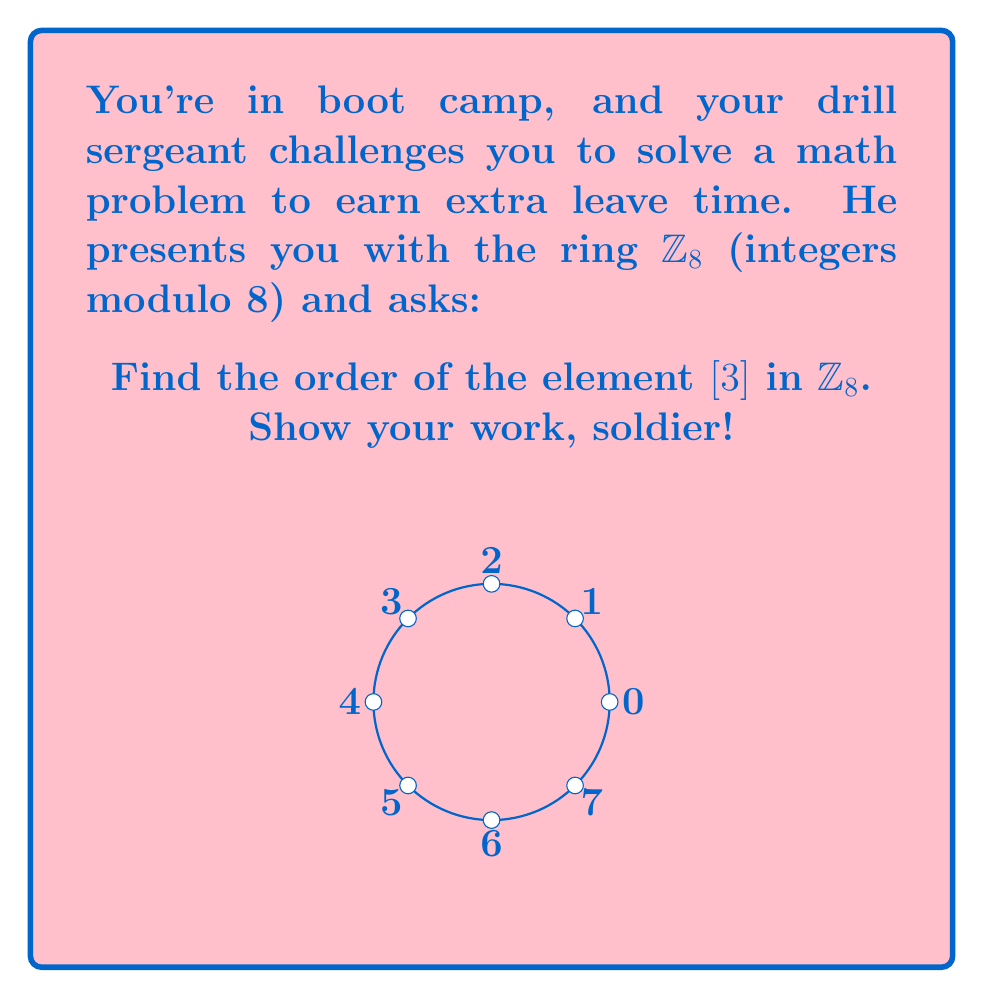Can you solve this math problem? To find the order of $[3]$ in $\mathbb{Z}_8$, we need to determine the smallest positive integer $n$ such that $[3]^n = [1]$ (the multiplicative identity in $\mathbb{Z}_8$).

Let's compute the powers of $[3]$ in $\mathbb{Z}_8$:

1) $[3]^1 = [3]$
2) $[3]^2 = [3] \cdot [3] = [9] = [1]$ (since $9 \equiv 1 \pmod{8}$)

We've found that $[3]^2 = [1]$, so the order of $[3]$ is 2.

To verify:
$$[3]^1 = [3] \neq [1]$$
$$[3]^2 = [1]$$

Therefore, 2 is indeed the smallest positive integer $n$ such that $[3]^n = [1]$.
Answer: 2 